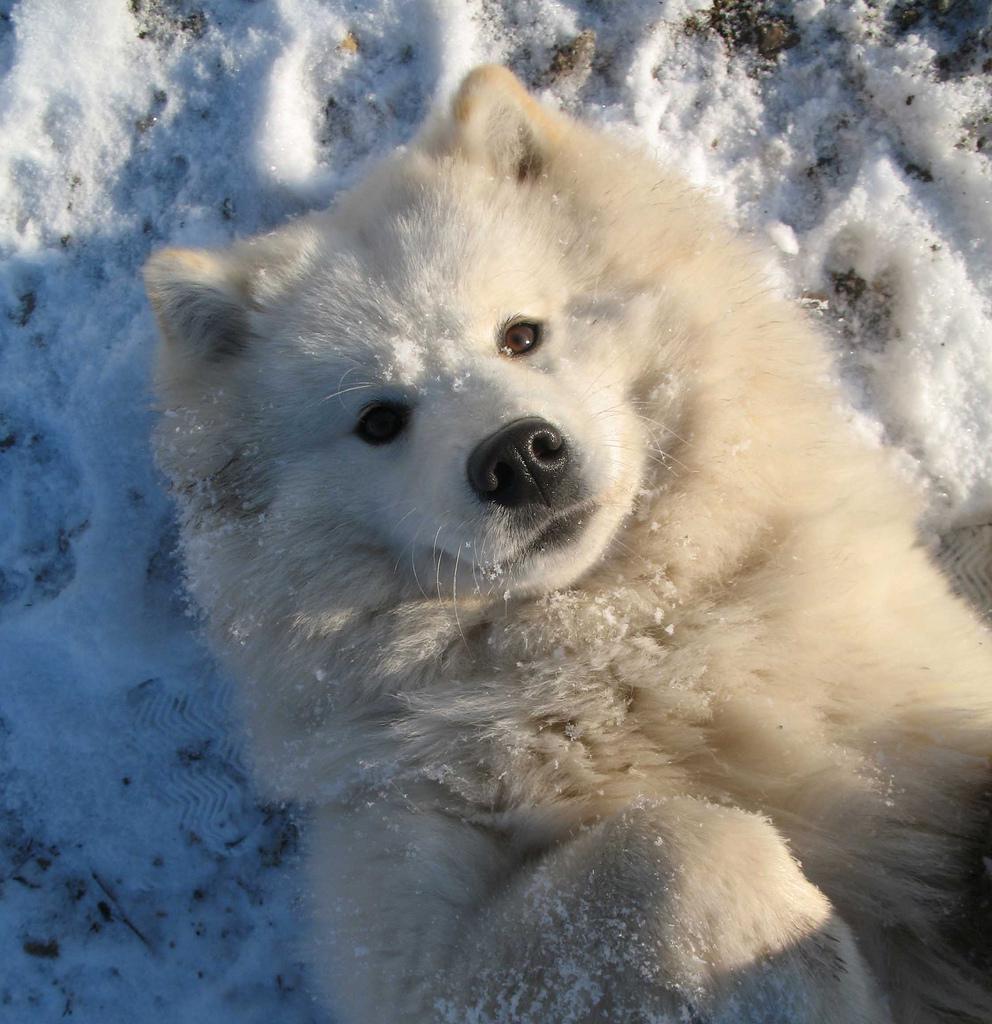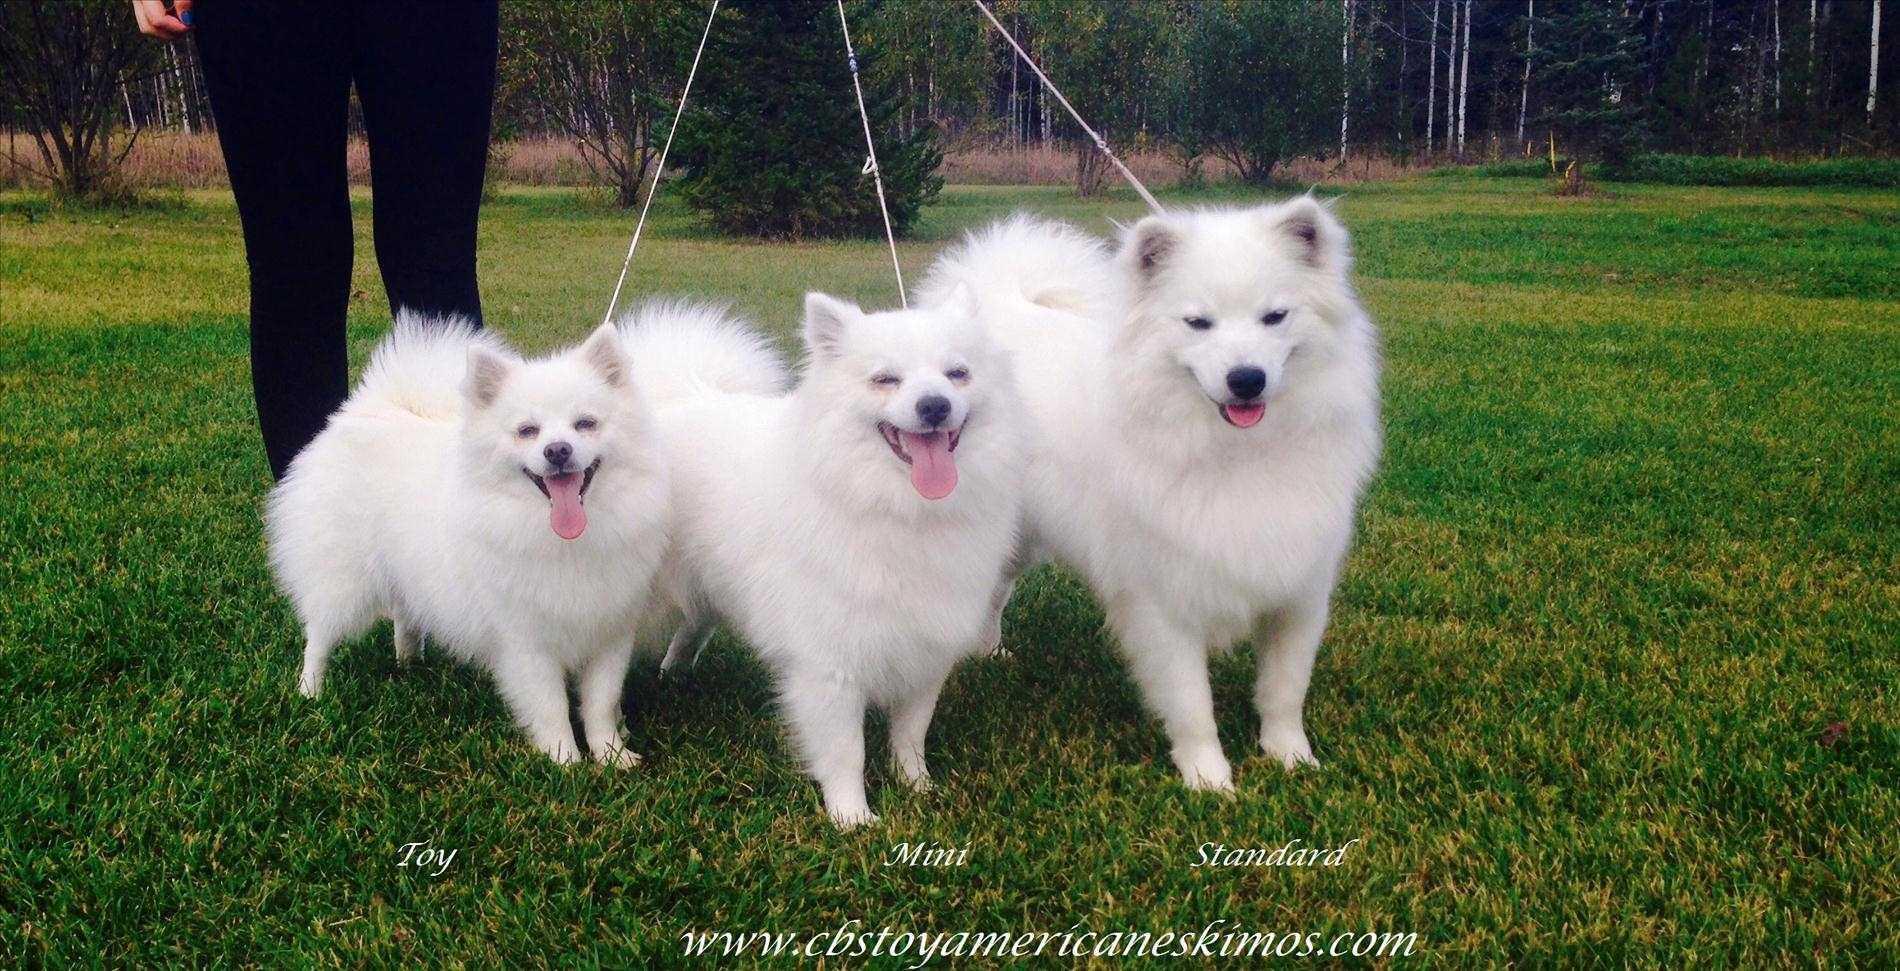The first image is the image on the left, the second image is the image on the right. Given the left and right images, does the statement "In one image, three white dogs are with a person." hold true? Answer yes or no. Yes. The first image is the image on the left, the second image is the image on the right. Analyze the images presented: Is the assertion "A person is visible behind three white dogs in one image." valid? Answer yes or no. Yes. 